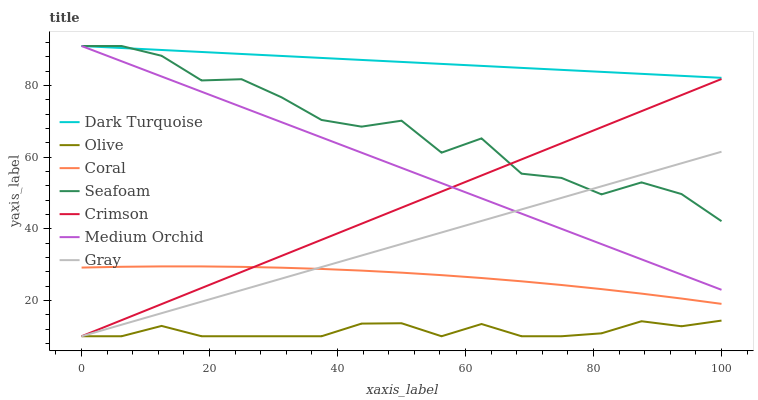Does Olive have the minimum area under the curve?
Answer yes or no. Yes. Does Dark Turquoise have the maximum area under the curve?
Answer yes or no. Yes. Does Coral have the minimum area under the curve?
Answer yes or no. No. Does Coral have the maximum area under the curve?
Answer yes or no. No. Is Crimson the smoothest?
Answer yes or no. Yes. Is Seafoam the roughest?
Answer yes or no. Yes. Is Dark Turquoise the smoothest?
Answer yes or no. No. Is Dark Turquoise the roughest?
Answer yes or no. No. Does Gray have the lowest value?
Answer yes or no. Yes. Does Coral have the lowest value?
Answer yes or no. No. Does Seafoam have the highest value?
Answer yes or no. Yes. Does Coral have the highest value?
Answer yes or no. No. Is Olive less than Coral?
Answer yes or no. Yes. Is Dark Turquoise greater than Olive?
Answer yes or no. Yes. Does Seafoam intersect Crimson?
Answer yes or no. Yes. Is Seafoam less than Crimson?
Answer yes or no. No. Is Seafoam greater than Crimson?
Answer yes or no. No. Does Olive intersect Coral?
Answer yes or no. No. 